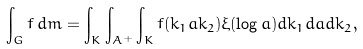Convert formula to latex. <formula><loc_0><loc_0><loc_500><loc_500>\int _ { G } f \, d m = \int _ { K } \int _ { A ^ { + } } \int _ { K } f ( k _ { 1 } a k _ { 2 } ) \xi ( \log a ) d k _ { 1 } d a d k _ { 2 } ,</formula> 